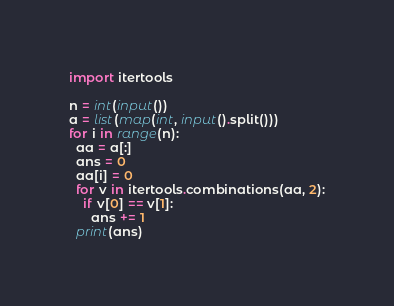Convert code to text. <code><loc_0><loc_0><loc_500><loc_500><_Python_>import itertools

n = int(input())
a = list(map(int, input().split()))
for i in range(n):
  aa = a[:]
  ans = 0
  aa[i] = 0
  for v in itertools.combinations(aa, 2):
    if v[0] == v[1]:
      ans += 1
  print(ans)

</code> 